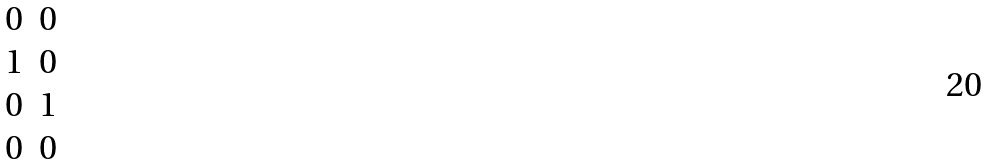Convert formula to latex. <formula><loc_0><loc_0><loc_500><loc_500>\begin{matrix} 0 & 0 \\ 1 & 0 \\ 0 & 1 \\ 0 & 0 \end{matrix}</formula> 